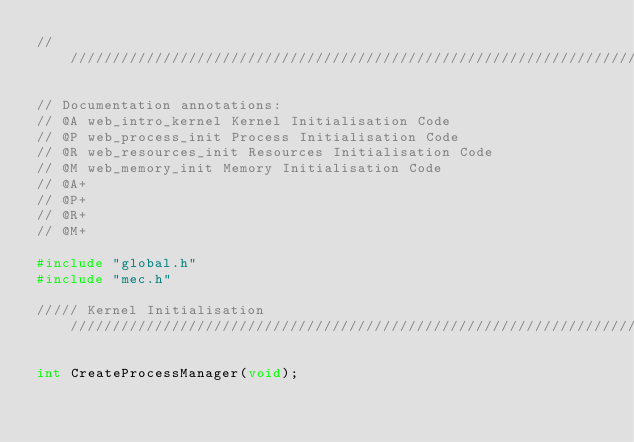Convert code to text. <code><loc_0><loc_0><loc_500><loc_500><_C_>///////////////////////////////////////////////////////////////////////////////////////////////////

// Documentation annotations:
// @A web_intro_kernel Kernel Initialisation Code
// @P web_process_init Process Initialisation Code
// @R web_resources_init Resources Initialisation Code
// @M web_memory_init Memory Initialisation Code
// @A+
// @P+
// @R+
// @M+

#include "global.h"
#include "mec.h"

///// Kernel Initialisation ///////////////////////////////////////////////////////////////////////

int CreateProcessManager(void);</code> 